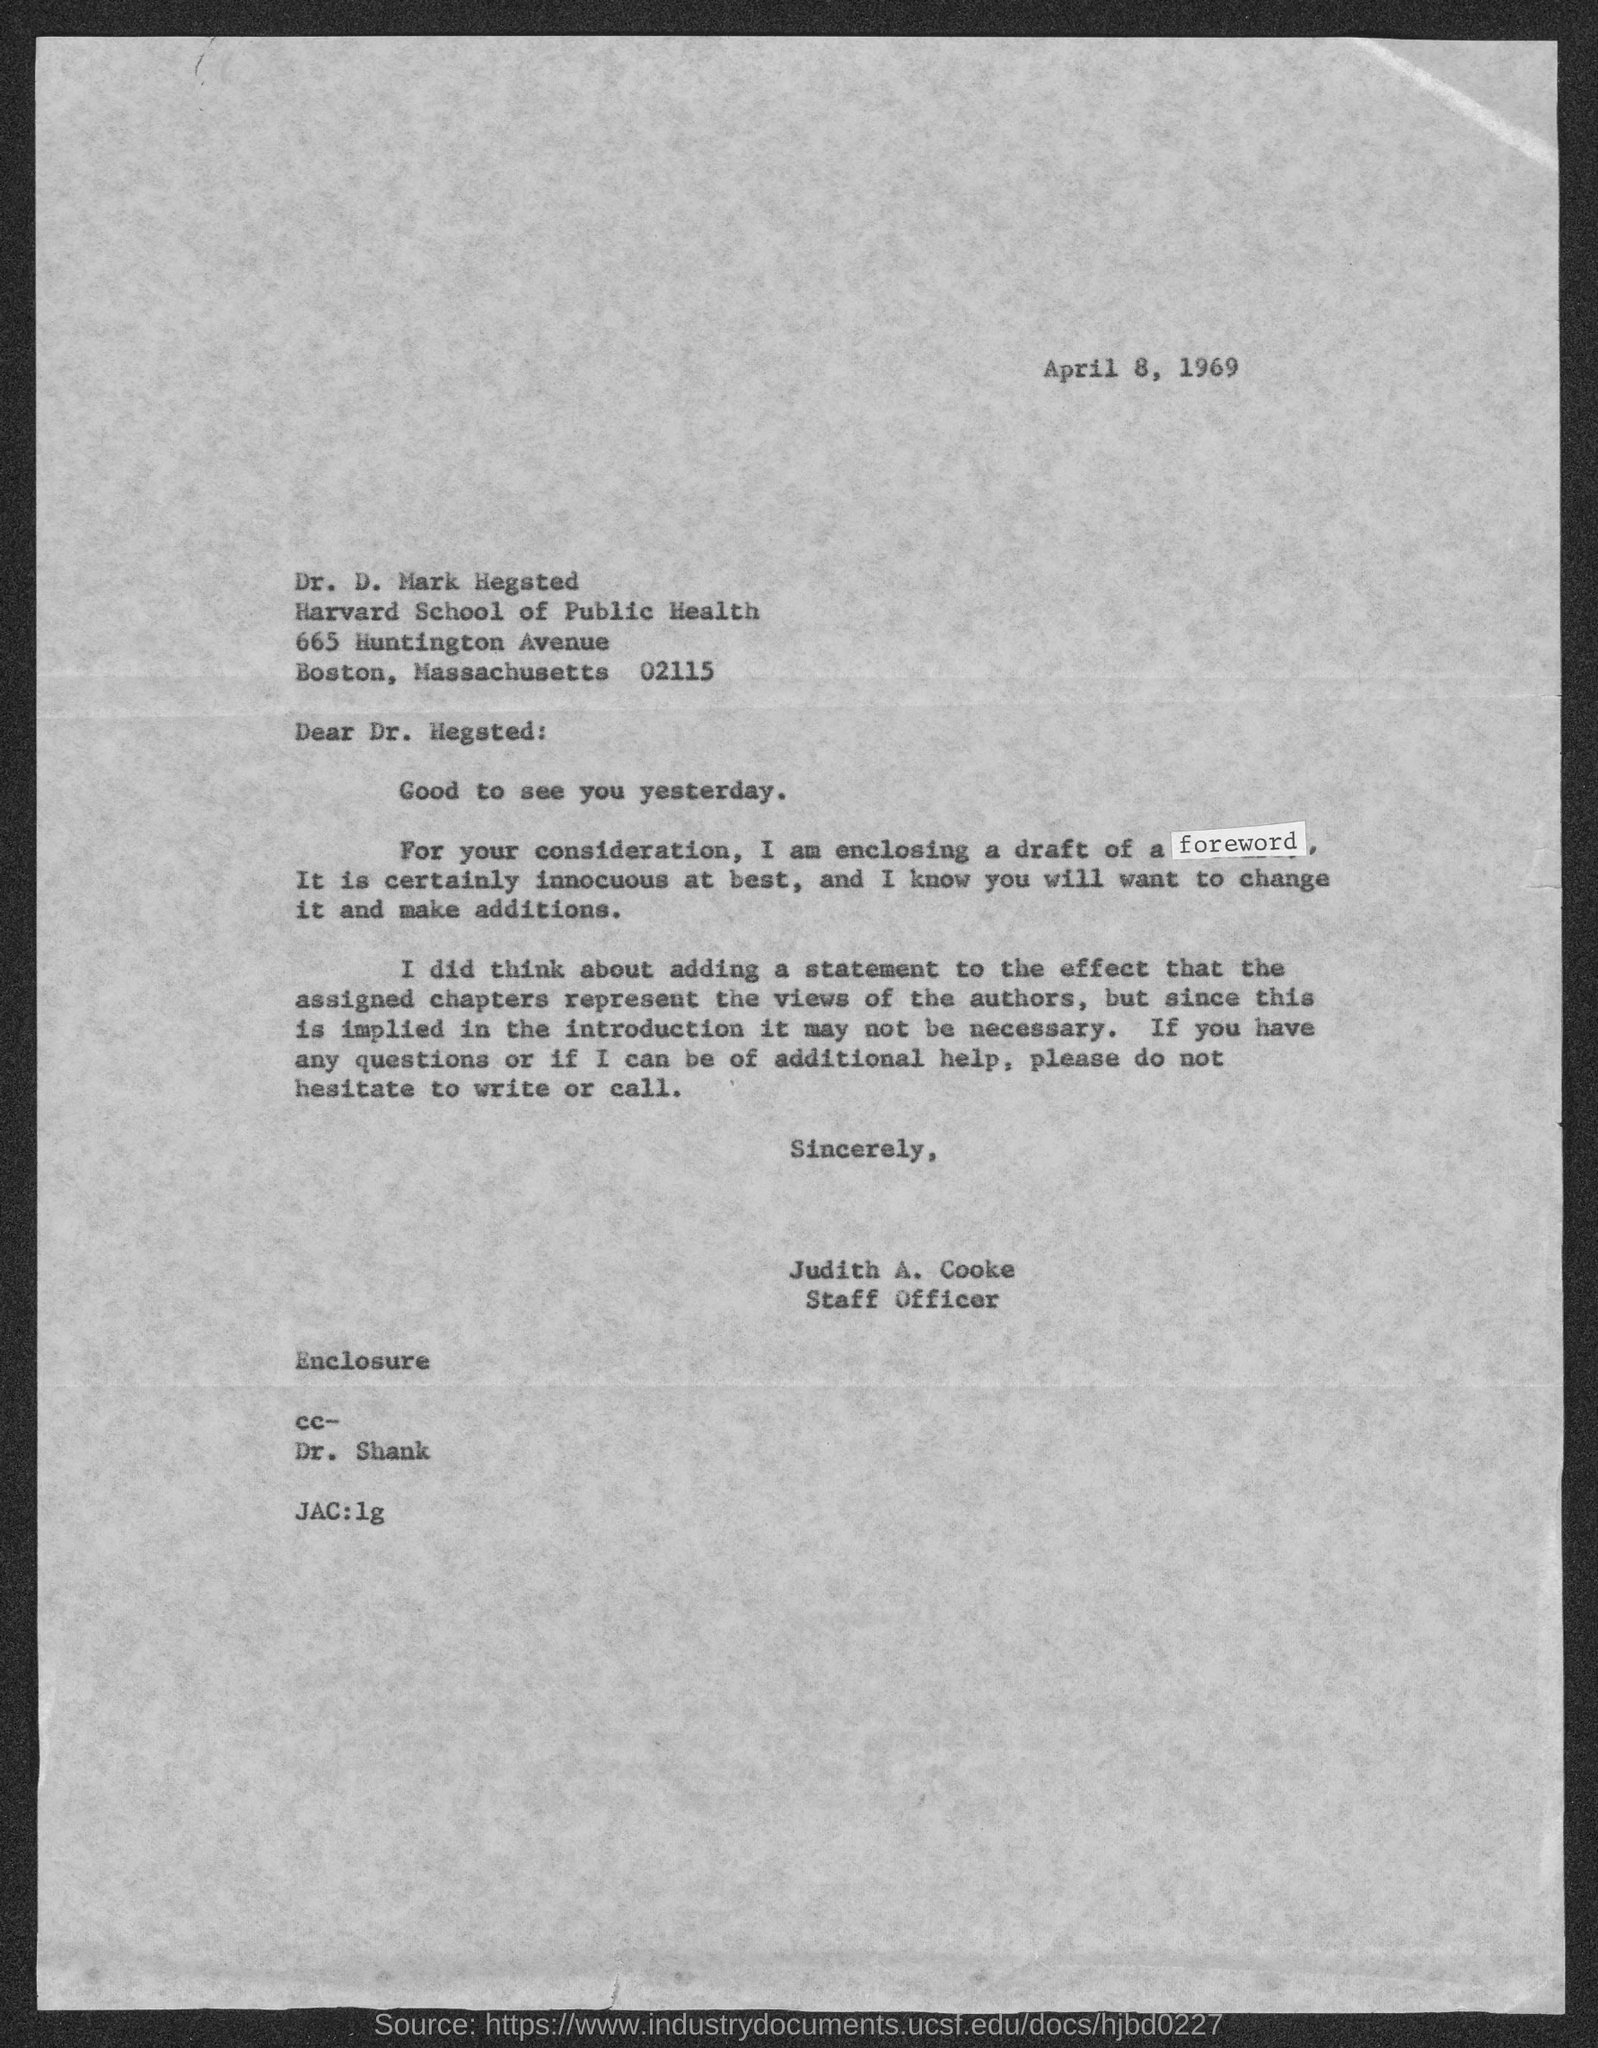Outline some significant characteristics in this image. This letter was delivered by Judith A. Cooke. Dr. D. Mark Hegsted belongs to the Harvard School of Public Health. Judith A. Cooke holds the designation of a staff officer. The date mentioned in the given letter is April 8, 1969. 